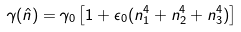Convert formula to latex. <formula><loc_0><loc_0><loc_500><loc_500>\gamma ( \hat { n } ) = \gamma _ { 0 } \left [ 1 + \epsilon _ { 0 } ( n _ { 1 } ^ { 4 } + n _ { 2 } ^ { 4 } + n _ { 3 } ^ { 4 } ) \right ]</formula> 